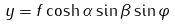<formula> <loc_0><loc_0><loc_500><loc_500>y = f \cosh \alpha \sin \beta \sin \varphi \\</formula> 